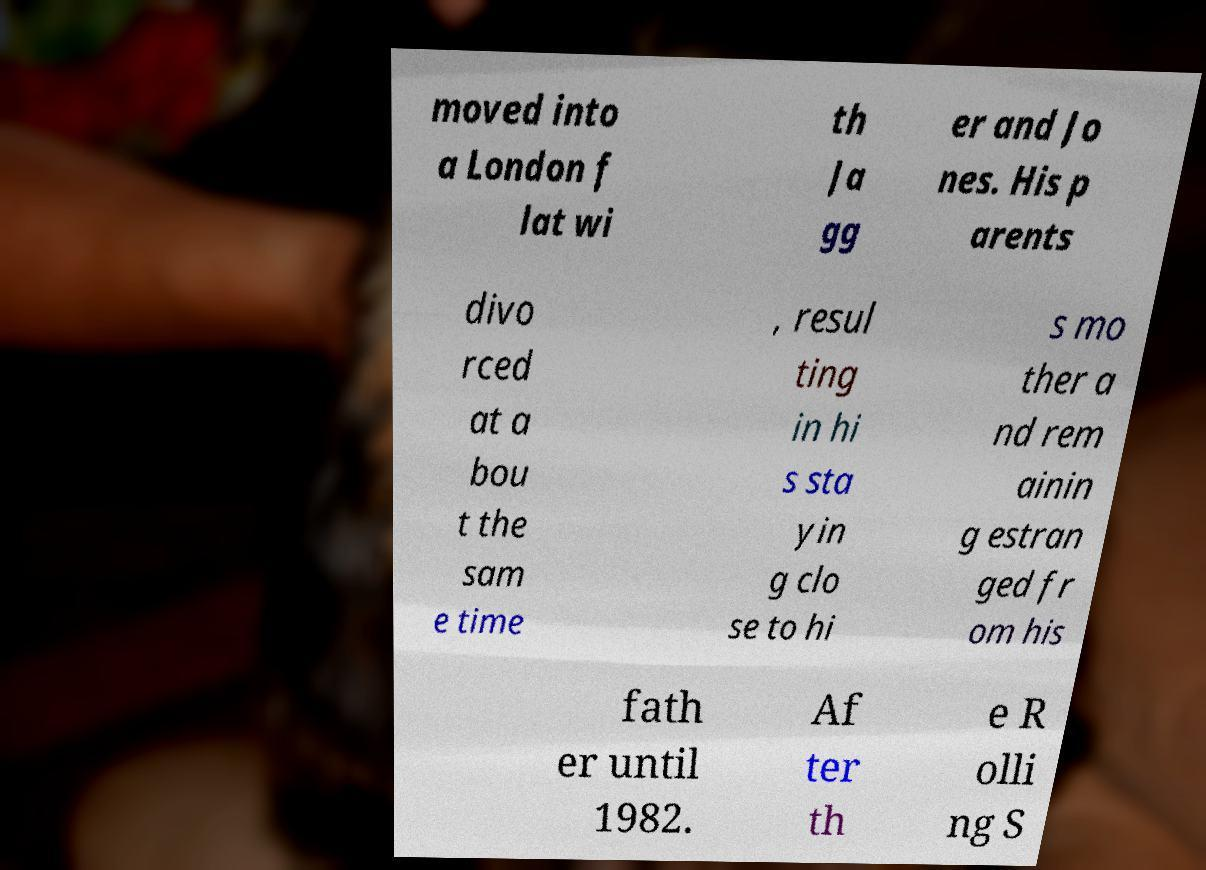There's text embedded in this image that I need extracted. Can you transcribe it verbatim? moved into a London f lat wi th Ja gg er and Jo nes. His p arents divo rced at a bou t the sam e time , resul ting in hi s sta yin g clo se to hi s mo ther a nd rem ainin g estran ged fr om his fath er until 1982. Af ter th e R olli ng S 